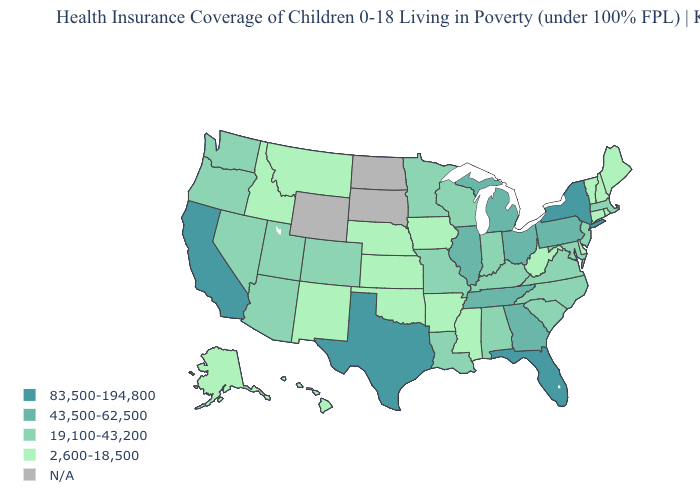How many symbols are there in the legend?
Be succinct. 5. Which states hav the highest value in the MidWest?
Answer briefly. Illinois, Michigan, Ohio. Name the states that have a value in the range 19,100-43,200?
Quick response, please. Alabama, Arizona, Colorado, Indiana, Kentucky, Louisiana, Maryland, Massachusetts, Minnesota, Missouri, Nevada, New Jersey, North Carolina, Oregon, South Carolina, Utah, Virginia, Washington, Wisconsin. Among the states that border New York , does Massachusetts have the lowest value?
Be succinct. No. Name the states that have a value in the range N/A?
Short answer required. North Dakota, South Dakota, Wyoming. Among the states that border Connecticut , does Massachusetts have the highest value?
Be succinct. No. Name the states that have a value in the range 19,100-43,200?
Quick response, please. Alabama, Arizona, Colorado, Indiana, Kentucky, Louisiana, Maryland, Massachusetts, Minnesota, Missouri, Nevada, New Jersey, North Carolina, Oregon, South Carolina, Utah, Virginia, Washington, Wisconsin. Among the states that border New Jersey , does Delaware have the lowest value?
Give a very brief answer. Yes. Among the states that border New Hampshire , does Massachusetts have the highest value?
Short answer required. Yes. What is the value of Idaho?
Quick response, please. 2,600-18,500. Does Louisiana have the lowest value in the South?
Write a very short answer. No. Name the states that have a value in the range 43,500-62,500?
Concise answer only. Georgia, Illinois, Michigan, Ohio, Pennsylvania, Tennessee. Which states have the highest value in the USA?
Be succinct. California, Florida, New York, Texas. Is the legend a continuous bar?
Write a very short answer. No. 